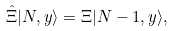<formula> <loc_0><loc_0><loc_500><loc_500>\hat { \Xi } { | N , { y } \rangle } = \Xi { | N - 1 , { y } \rangle } ,</formula> 